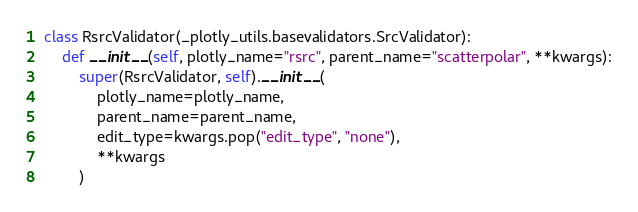<code> <loc_0><loc_0><loc_500><loc_500><_Python_>

class RsrcValidator(_plotly_utils.basevalidators.SrcValidator):
    def __init__(self, plotly_name="rsrc", parent_name="scatterpolar", **kwargs):
        super(RsrcValidator, self).__init__(
            plotly_name=plotly_name,
            parent_name=parent_name,
            edit_type=kwargs.pop("edit_type", "none"),
            **kwargs
        )
</code> 